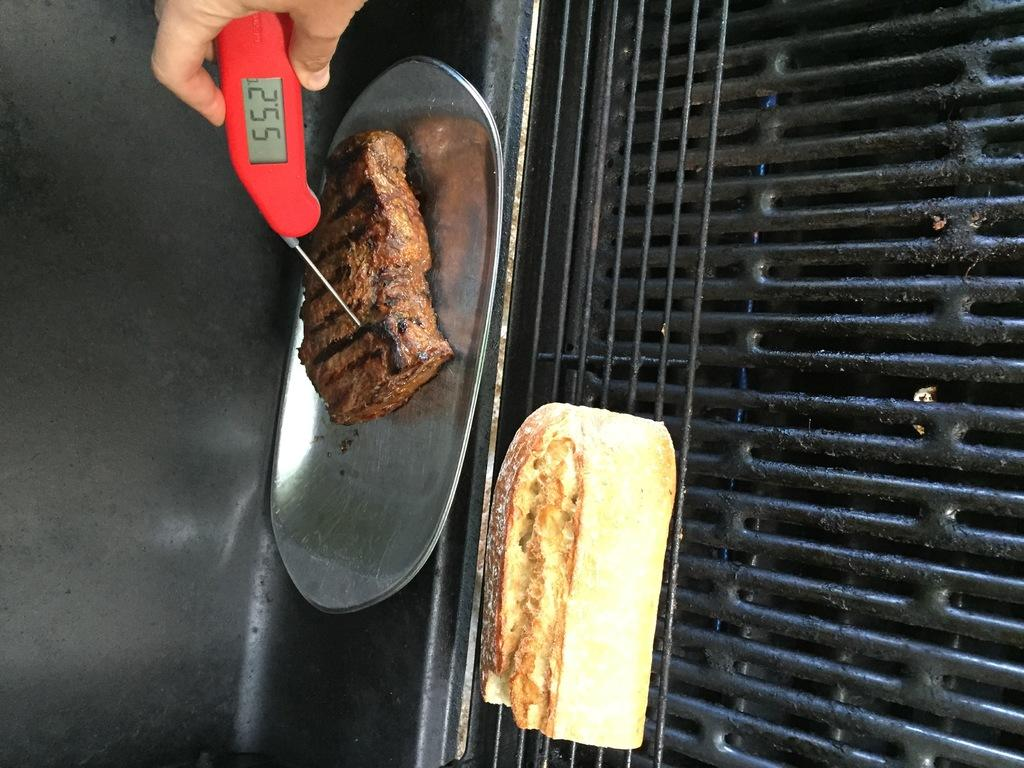<image>
Give a short and clear explanation of the subsequent image. Checking the steak's internal temperature which is 55.2 degrees. 